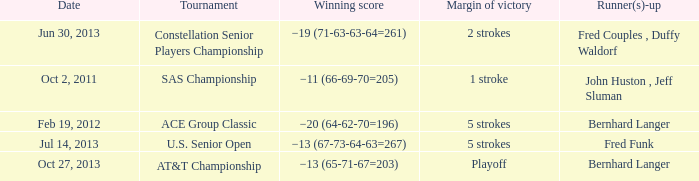Which Date has a Runner(s)-up of bernhard langer, and a Tournament of at&t championship? Oct 27, 2013. 